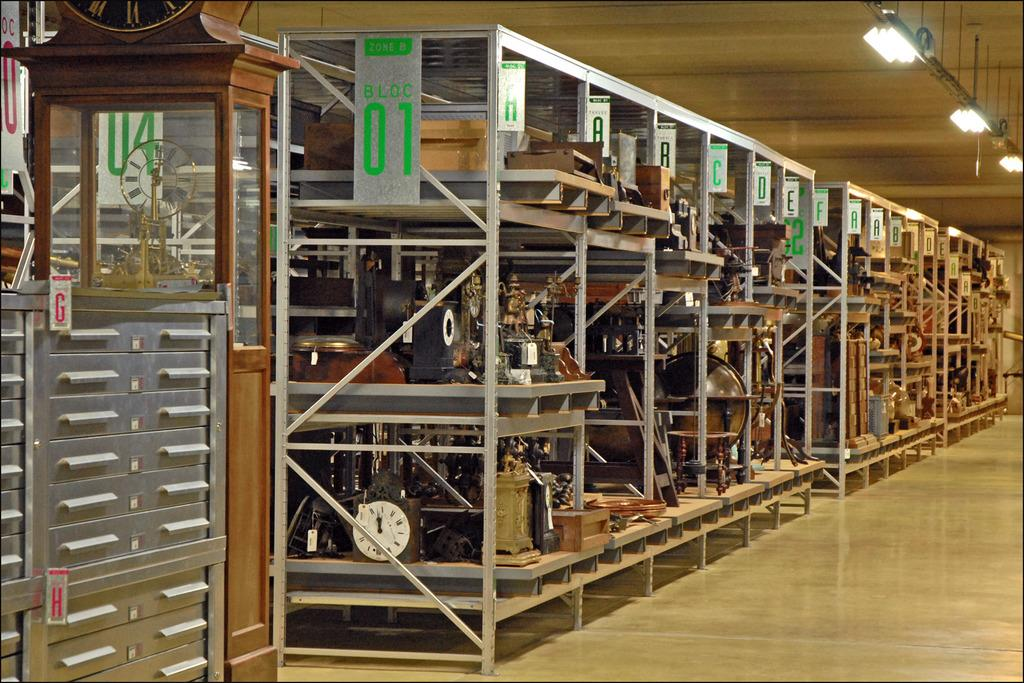<image>
Present a compact description of the photo's key features. a cabinet to store small items labelled G 